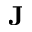<formula> <loc_0><loc_0><loc_500><loc_500>J</formula> 